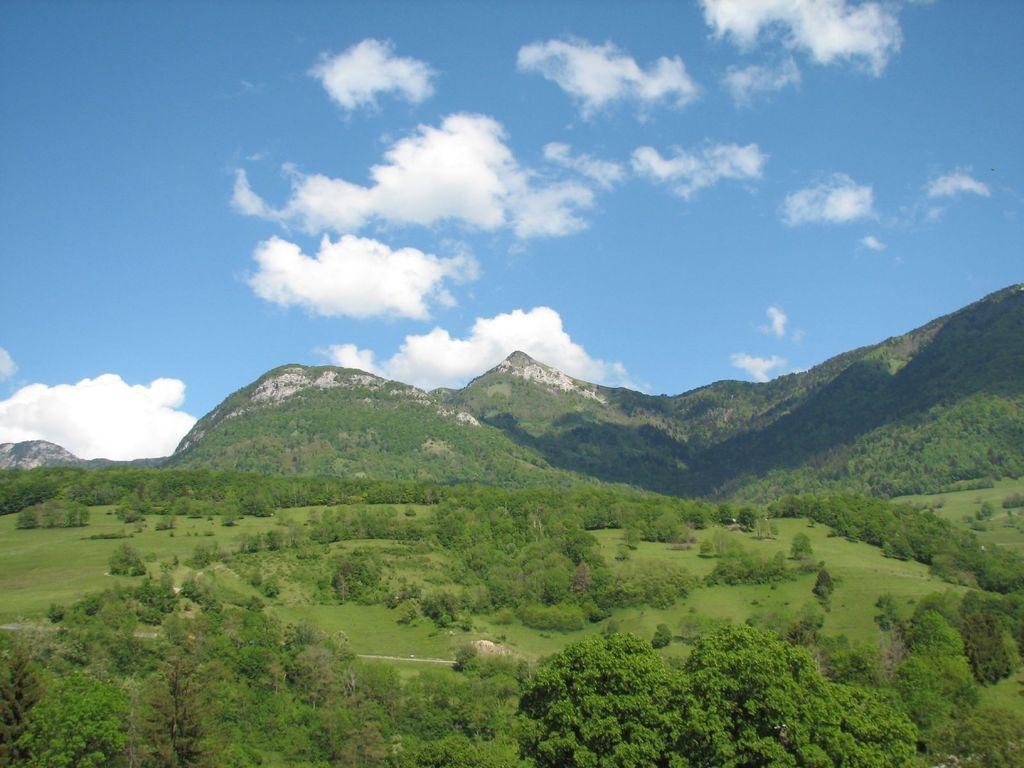Can you describe this image briefly? In this image, there are a few hills, plants and trees. We can see the ground with some grass. We can also see the sky with clouds. 